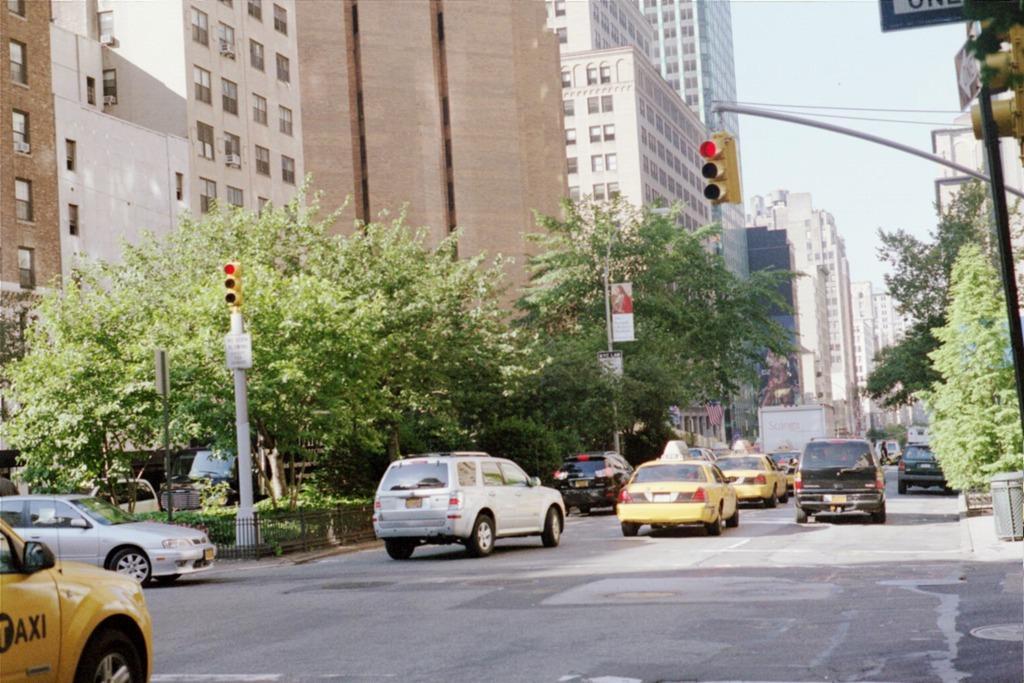Can you describe this image briefly? In this image these are few cars and vehicles are on the road. There is a dustbin on the pavement. Right side there is a pole having few boards attached to it. Behind it there is a traffic light. A pole is having a traffic light attached to it. Behind there are few trees and buildings. Left side there is a yellow colour car. Behind the fence there is a pole having a traffic light attached to it. Behind it there are few trees, plants and vehicles. In background there are few buildings. Top of image there is sky. 